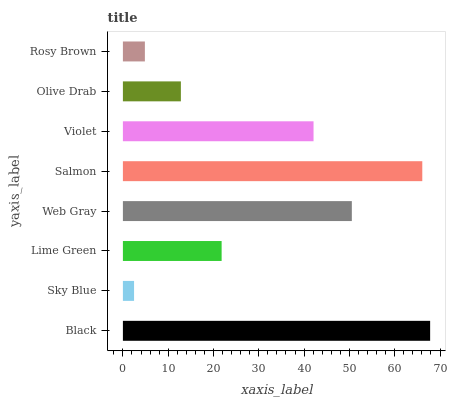Is Sky Blue the minimum?
Answer yes or no. Yes. Is Black the maximum?
Answer yes or no. Yes. Is Lime Green the minimum?
Answer yes or no. No. Is Lime Green the maximum?
Answer yes or no. No. Is Lime Green greater than Sky Blue?
Answer yes or no. Yes. Is Sky Blue less than Lime Green?
Answer yes or no. Yes. Is Sky Blue greater than Lime Green?
Answer yes or no. No. Is Lime Green less than Sky Blue?
Answer yes or no. No. Is Violet the high median?
Answer yes or no. Yes. Is Lime Green the low median?
Answer yes or no. Yes. Is Salmon the high median?
Answer yes or no. No. Is Black the low median?
Answer yes or no. No. 